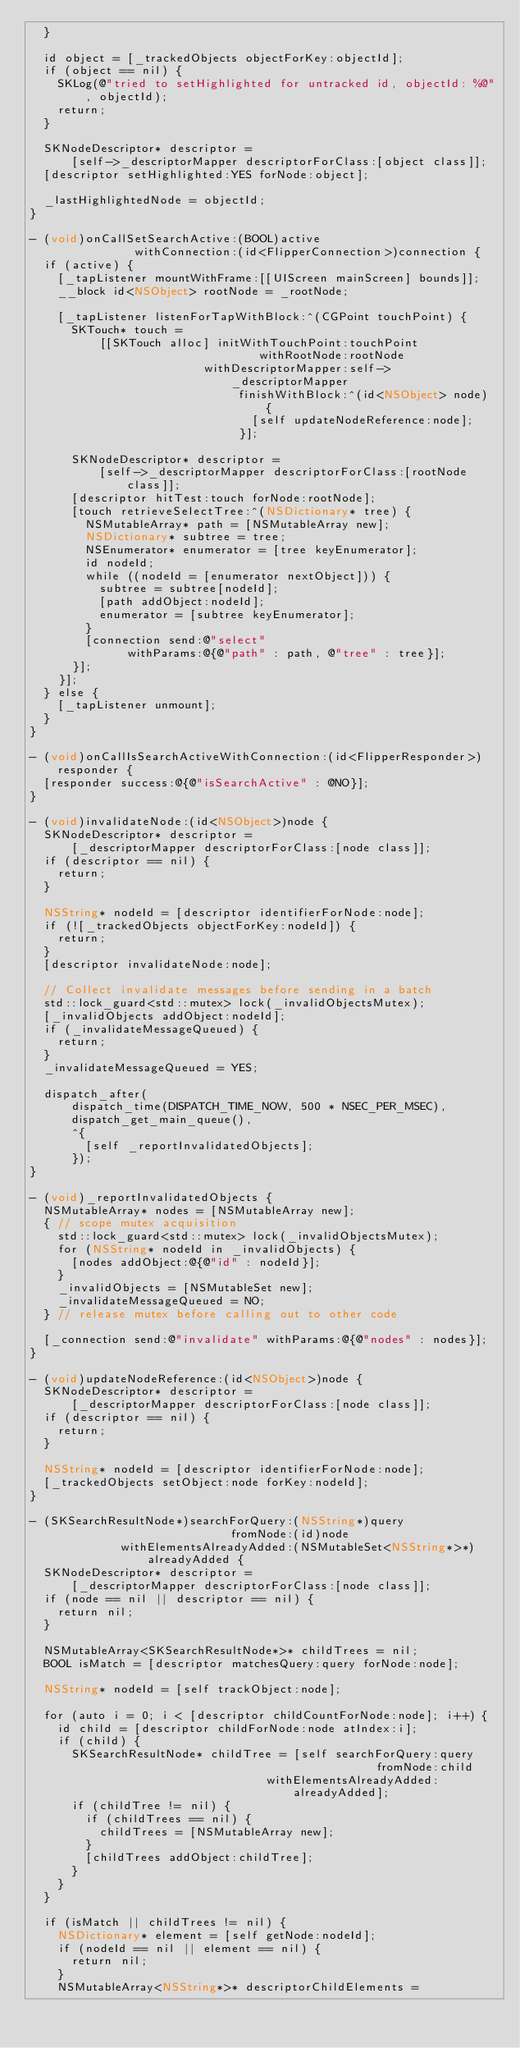Convert code to text. <code><loc_0><loc_0><loc_500><loc_500><_ObjectiveC_>  }

  id object = [_trackedObjects objectForKey:objectId];
  if (object == nil) {
    SKLog(@"tried to setHighlighted for untracked id, objectId: %@", objectId);
    return;
  }

  SKNodeDescriptor* descriptor =
      [self->_descriptorMapper descriptorForClass:[object class]];
  [descriptor setHighlighted:YES forNode:object];

  _lastHighlightedNode = objectId;
}

- (void)onCallSetSearchActive:(BOOL)active
               withConnection:(id<FlipperConnection>)connection {
  if (active) {
    [_tapListener mountWithFrame:[[UIScreen mainScreen] bounds]];
    __block id<NSObject> rootNode = _rootNode;

    [_tapListener listenForTapWithBlock:^(CGPoint touchPoint) {
      SKTouch* touch =
          [[SKTouch alloc] initWithTouchPoint:touchPoint
                                 withRootNode:rootNode
                         withDescriptorMapper:self->_descriptorMapper
                              finishWithBlock:^(id<NSObject> node) {
                                [self updateNodeReference:node];
                              }];

      SKNodeDescriptor* descriptor =
          [self->_descriptorMapper descriptorForClass:[rootNode class]];
      [descriptor hitTest:touch forNode:rootNode];
      [touch retrieveSelectTree:^(NSDictionary* tree) {
        NSMutableArray* path = [NSMutableArray new];
        NSDictionary* subtree = tree;
        NSEnumerator* enumerator = [tree keyEnumerator];
        id nodeId;
        while ((nodeId = [enumerator nextObject])) {
          subtree = subtree[nodeId];
          [path addObject:nodeId];
          enumerator = [subtree keyEnumerator];
        }
        [connection send:@"select"
              withParams:@{@"path" : path, @"tree" : tree}];
      }];
    }];
  } else {
    [_tapListener unmount];
  }
}

- (void)onCallIsSearchActiveWithConnection:(id<FlipperResponder>)responder {
  [responder success:@{@"isSearchActive" : @NO}];
}

- (void)invalidateNode:(id<NSObject>)node {
  SKNodeDescriptor* descriptor =
      [_descriptorMapper descriptorForClass:[node class]];
  if (descriptor == nil) {
    return;
  }

  NSString* nodeId = [descriptor identifierForNode:node];
  if (![_trackedObjects objectForKey:nodeId]) {
    return;
  }
  [descriptor invalidateNode:node];

  // Collect invalidate messages before sending in a batch
  std::lock_guard<std::mutex> lock(_invalidObjectsMutex);
  [_invalidObjects addObject:nodeId];
  if (_invalidateMessageQueued) {
    return;
  }
  _invalidateMessageQueued = YES;

  dispatch_after(
      dispatch_time(DISPATCH_TIME_NOW, 500 * NSEC_PER_MSEC),
      dispatch_get_main_queue(),
      ^{
        [self _reportInvalidatedObjects];
      });
}

- (void)_reportInvalidatedObjects {
  NSMutableArray* nodes = [NSMutableArray new];
  { // scope mutex acquisition
    std::lock_guard<std::mutex> lock(_invalidObjectsMutex);
    for (NSString* nodeId in _invalidObjects) {
      [nodes addObject:@{@"id" : nodeId}];
    }
    _invalidObjects = [NSMutableSet new];
    _invalidateMessageQueued = NO;
  } // release mutex before calling out to other code

  [_connection send:@"invalidate" withParams:@{@"nodes" : nodes}];
}

- (void)updateNodeReference:(id<NSObject>)node {
  SKNodeDescriptor* descriptor =
      [_descriptorMapper descriptorForClass:[node class]];
  if (descriptor == nil) {
    return;
  }

  NSString* nodeId = [descriptor identifierForNode:node];
  [_trackedObjects setObject:node forKey:nodeId];
}

- (SKSearchResultNode*)searchForQuery:(NSString*)query
                             fromNode:(id)node
             withElementsAlreadyAdded:(NSMutableSet<NSString*>*)alreadyAdded {
  SKNodeDescriptor* descriptor =
      [_descriptorMapper descriptorForClass:[node class]];
  if (node == nil || descriptor == nil) {
    return nil;
  }

  NSMutableArray<SKSearchResultNode*>* childTrees = nil;
  BOOL isMatch = [descriptor matchesQuery:query forNode:node];

  NSString* nodeId = [self trackObject:node];

  for (auto i = 0; i < [descriptor childCountForNode:node]; i++) {
    id child = [descriptor childForNode:node atIndex:i];
    if (child) {
      SKSearchResultNode* childTree = [self searchForQuery:query
                                                  fromNode:child
                                  withElementsAlreadyAdded:alreadyAdded];
      if (childTree != nil) {
        if (childTrees == nil) {
          childTrees = [NSMutableArray new];
        }
        [childTrees addObject:childTree];
      }
    }
  }

  if (isMatch || childTrees != nil) {
    NSDictionary* element = [self getNode:nodeId];
    if (nodeId == nil || element == nil) {
      return nil;
    }
    NSMutableArray<NSString*>* descriptorChildElements =</code> 